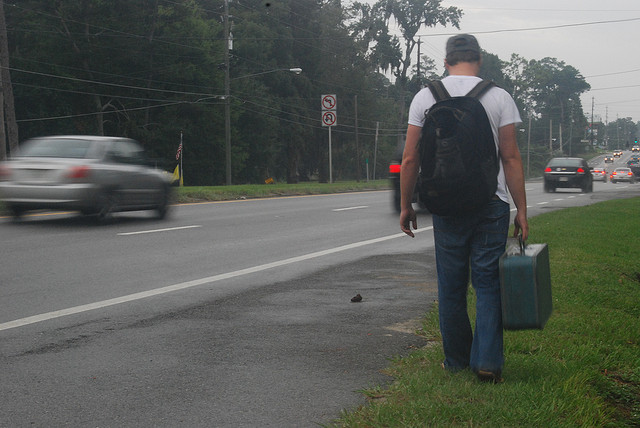<image>Why isn't he on a sidewalk? It is unknown why he isn't on a sidewalk. It could be that there isn't one or the sidewalk is ending. Why isn't he on a sidewalk? There is no sidewalk in the image. 